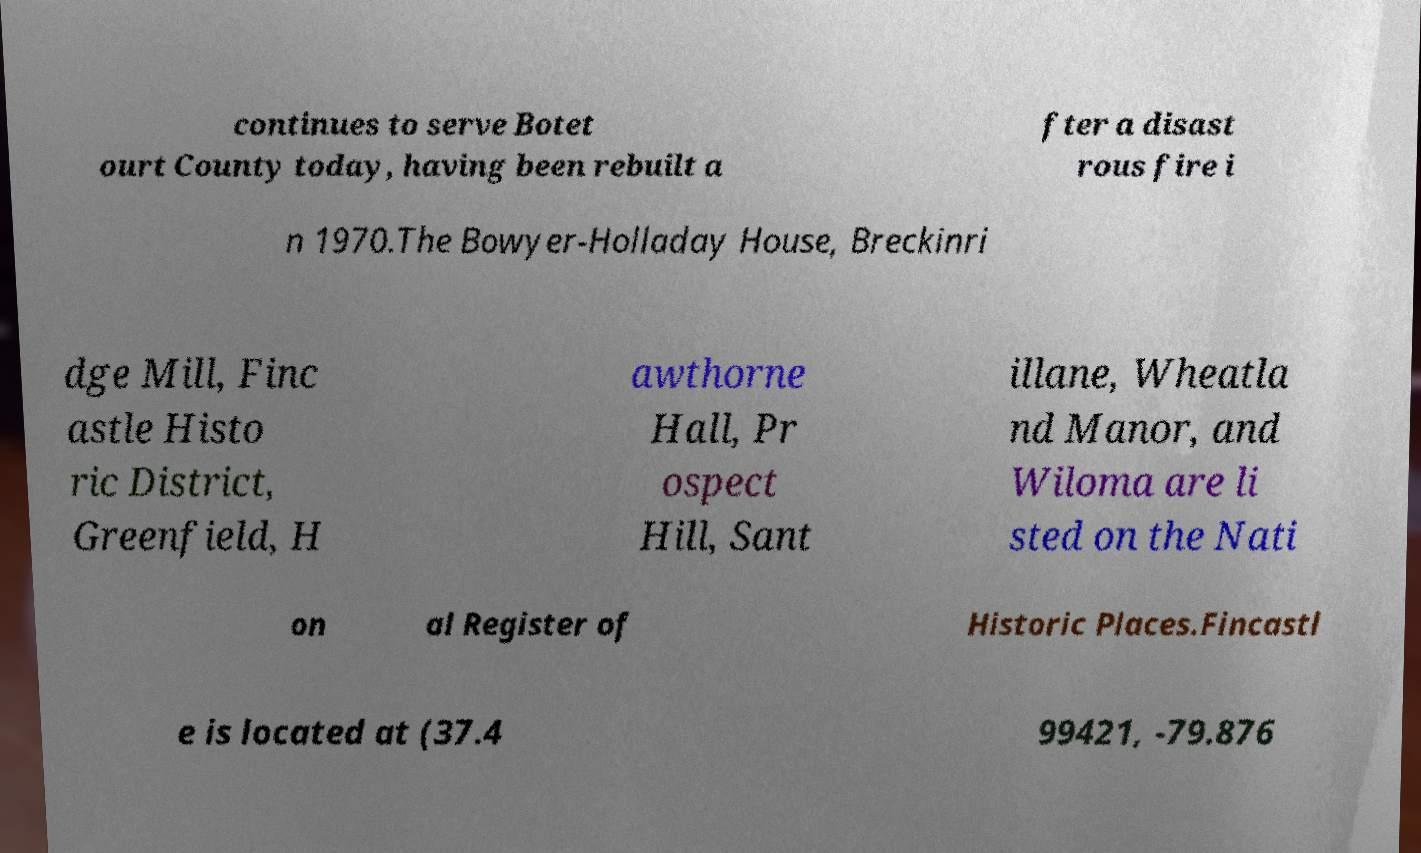There's text embedded in this image that I need extracted. Can you transcribe it verbatim? continues to serve Botet ourt County today, having been rebuilt a fter a disast rous fire i n 1970.The Bowyer-Holladay House, Breckinri dge Mill, Finc astle Histo ric District, Greenfield, H awthorne Hall, Pr ospect Hill, Sant illane, Wheatla nd Manor, and Wiloma are li sted on the Nati on al Register of Historic Places.Fincastl e is located at (37.4 99421, -79.876 